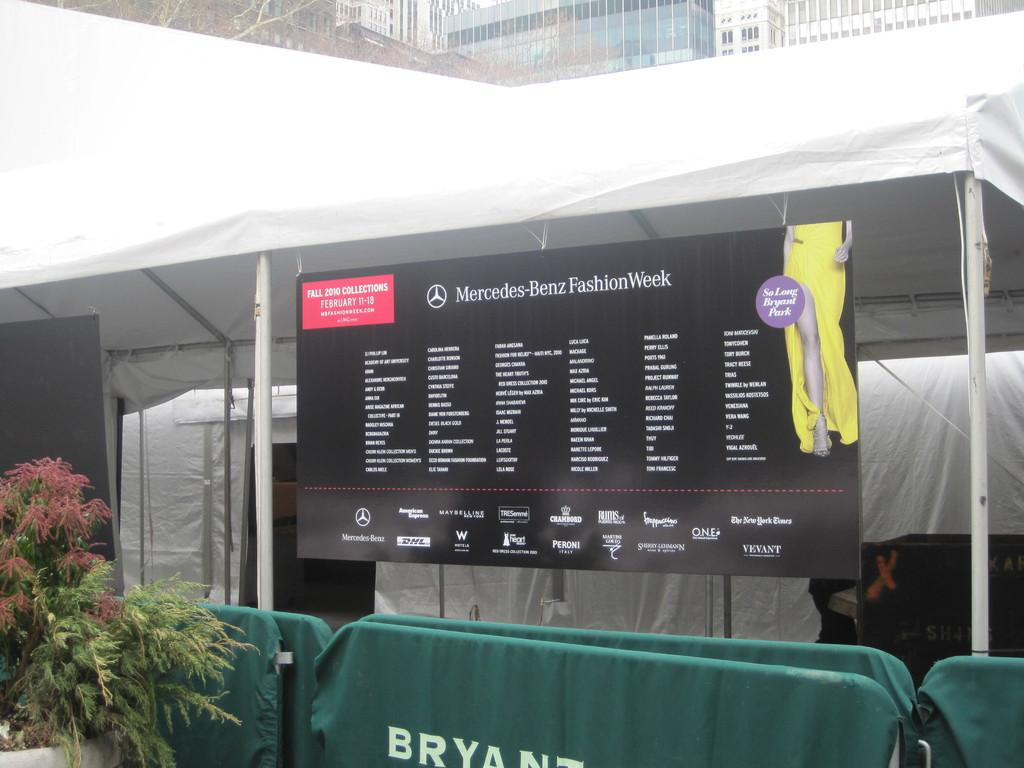What is hanging or displayed in the image? There is a banner in the image. What structure can be seen in the image? There is a tent in the image. What type of vegetation is on the left side of the image? There are plants on the left side of the image. What can be seen in the distance in the image? There are buildings in the background of the image. What type of nerve can be seen in the image? There is no nerve present in the image. Can you see the person's mom in the image? There is no person or their mom depicted in the image. 